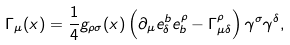<formula> <loc_0><loc_0><loc_500><loc_500>\Gamma _ { \mu } ( x ) = \frac { 1 } { 4 } g _ { \rho \sigma } ( x ) \left ( \partial _ { \mu } e _ { \delta } ^ { b } e _ { b } ^ { \rho } - \Gamma _ { \mu \delta } ^ { \rho } \right ) \gamma ^ { \sigma } \gamma ^ { \delta } ,</formula> 